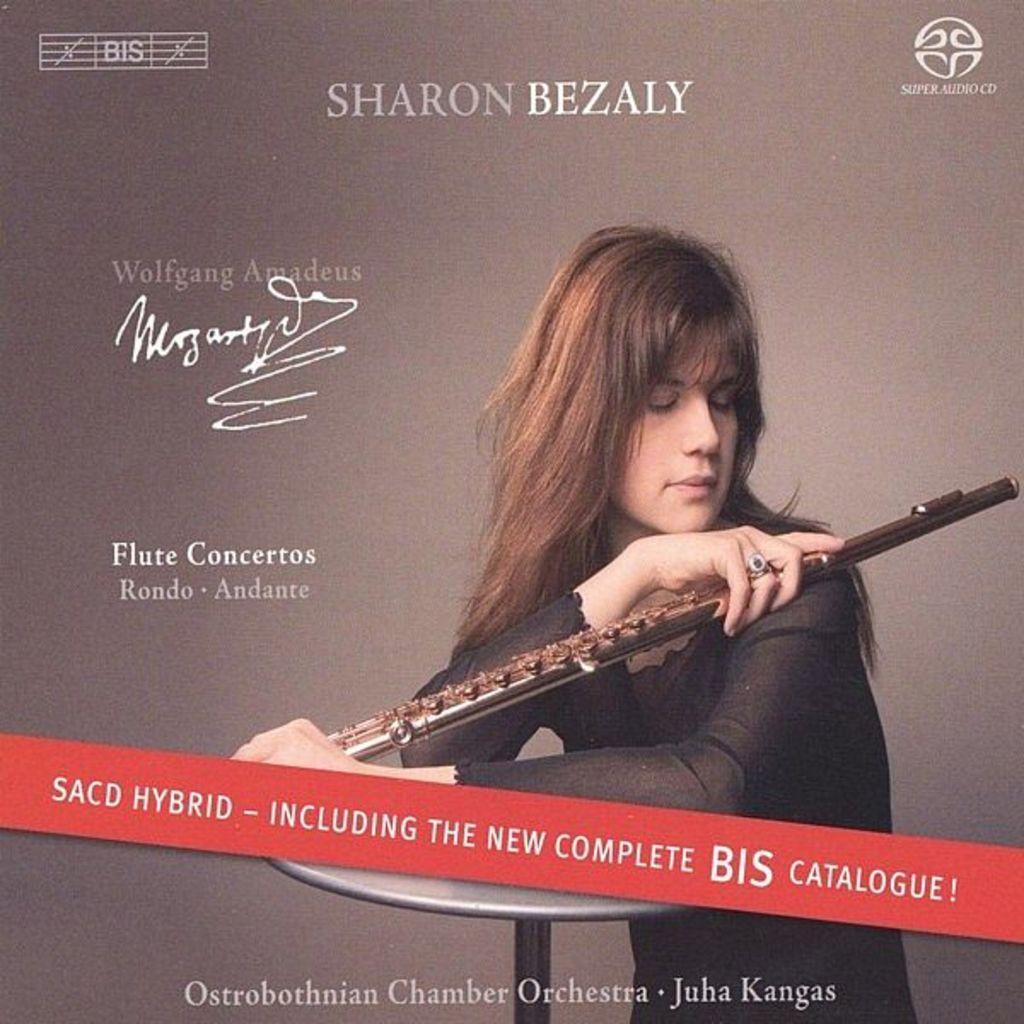In one or two sentences, can you explain what this image depicts? In the picture we can see an advertisement poster on it, we can see a woman standing near the table and a holding a flute and she is in a black dress and beside her written as flute concertos. 